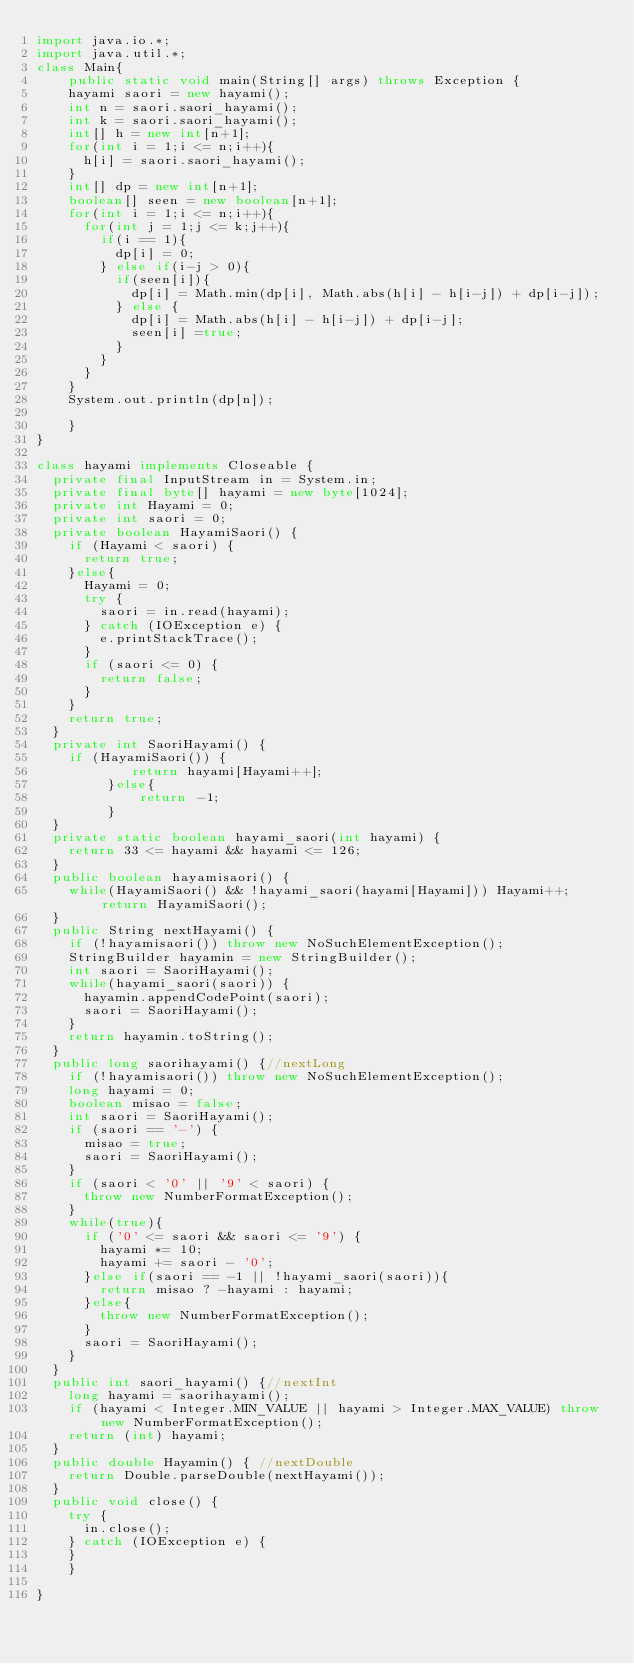<code> <loc_0><loc_0><loc_500><loc_500><_Java_>import java.io.*;
import java.util.*;
class Main{
    public static void main(String[] args) throws Exception {
		hayami saori = new hayami();
		int n = saori.saori_hayami();
		int k = saori.saori_hayami();
		int[] h = new int[n+1];
		for(int i = 1;i <= n;i++){
			h[i] = saori.saori_hayami();
		}
		int[] dp = new int[n+1];
		boolean[] seen = new boolean[n+1];
		for(int i = 1;i <= n;i++){
			for(int j = 1;j <= k;j++){
				if(i == 1){
					dp[i] = 0;
				} else if(i-j > 0){
					if(seen[i]){
						dp[i] = Math.min(dp[i], Math.abs(h[i] - h[i-j]) + dp[i-j]);
					} else {
						dp[i] = Math.abs(h[i] - h[i-j]) + dp[i-j];
						seen[i] =true;
					}					
				}
			}
		}
		System.out.println(dp[n]);
		
    }
}

class hayami implements Closeable {
	private final InputStream in = System.in;
	private final byte[] hayami = new byte[1024];
	private int Hayami = 0;
	private int saori = 0;
	private boolean HayamiSaori() {
		if (Hayami < saori) {
			return true;
		}else{
			Hayami = 0;
			try {
				saori = in.read(hayami);
			} catch (IOException e) {
				e.printStackTrace();
			}
			if (saori <= 0) {
				return false;
			}
		}
		return true;
	}
	private int SaoriHayami() { 
		if (HayamiSaori()) {
            return hayami[Hayami++];
         }else{
             return -1;
         }
	}
	private static boolean hayami_saori(int hayami) { 
		return 33 <= hayami && hayami <= 126;
	}
	public boolean hayamisaori() { 
		while(HayamiSaori() && !hayami_saori(hayami[Hayami])) Hayami++; return HayamiSaori();
	}
	public String nextHayami() {
		if (!hayamisaori()) throw new NoSuchElementException();
		StringBuilder hayamin = new StringBuilder();
		int saori = SaoriHayami();
		while(hayami_saori(saori)) {
			hayamin.appendCodePoint(saori);
			saori = SaoriHayami();
		}
		return hayamin.toString();
	}
	public long saorihayami() {//nextLong
		if (!hayamisaori()) throw new NoSuchElementException();
		long hayami = 0;
		boolean misao = false;
		int saori = SaoriHayami();
		if (saori == '-') {
			misao = true;
			saori = SaoriHayami();
		}
		if (saori < '0' || '9' < saori) {
			throw new NumberFormatException();
		}
		while(true){
			if ('0' <= saori && saori <= '9') {
				hayami *= 10;
				hayami += saori - '0';
			}else if(saori == -1 || !hayami_saori(saori)){
				return misao ? -hayami : hayami;
			}else{
				throw new NumberFormatException();
			}
			saori = SaoriHayami();
		}
	}
	public int saori_hayami() {//nextInt
		long hayami = saorihayami();
		if (hayami < Integer.MIN_VALUE || hayami > Integer.MAX_VALUE) throw new NumberFormatException();
		return (int) hayami;
	}
	public double Hayamin() { //nextDouble
		return Double.parseDouble(nextHayami());
	}
	public void close() {
		try {
			in.close();
		} catch (IOException e) {
		}
    }
    
}</code> 